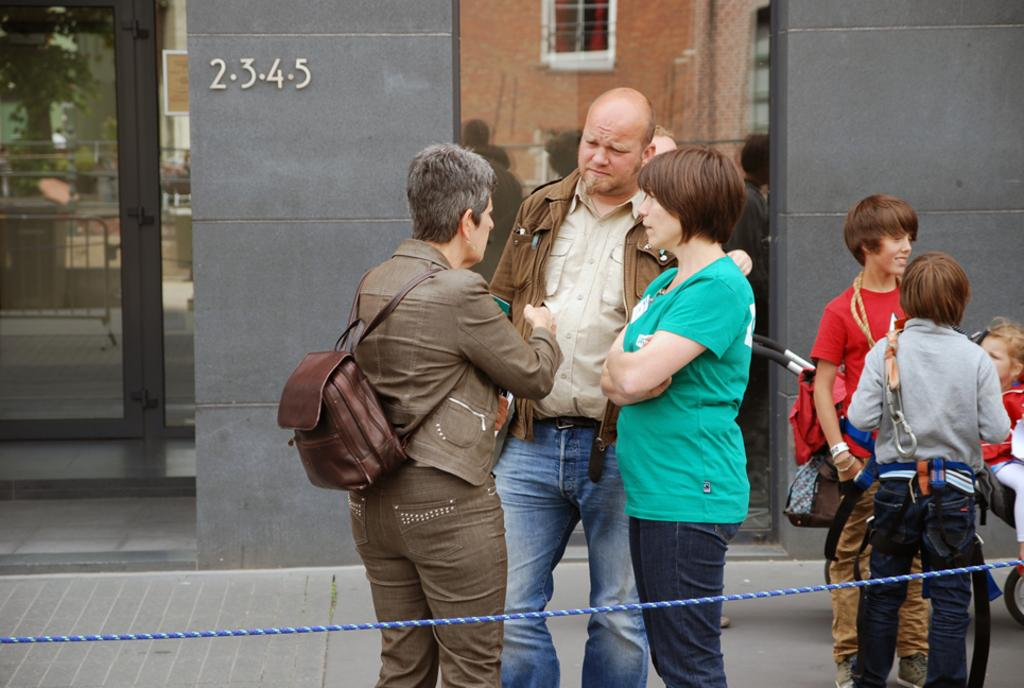What can be seen in the image involving a group of people? There is a group of people standing in the image. What object is present in the image that is typically used for tying or pulling? There is a rope in the image. What can be seen in the distance in the image? There is a building in the background of the image. What natural element is reflected in the image? There is a reflection of trees in the image. What type of barrier is visible in the image? There are iron grills in the image. What type of whistle is being used by the dad in the image? There is no dad or whistle present in the image. What time of day is depicted in the image? The provided facts do not give any information about the time of day, so it cannot be determined from the image. 